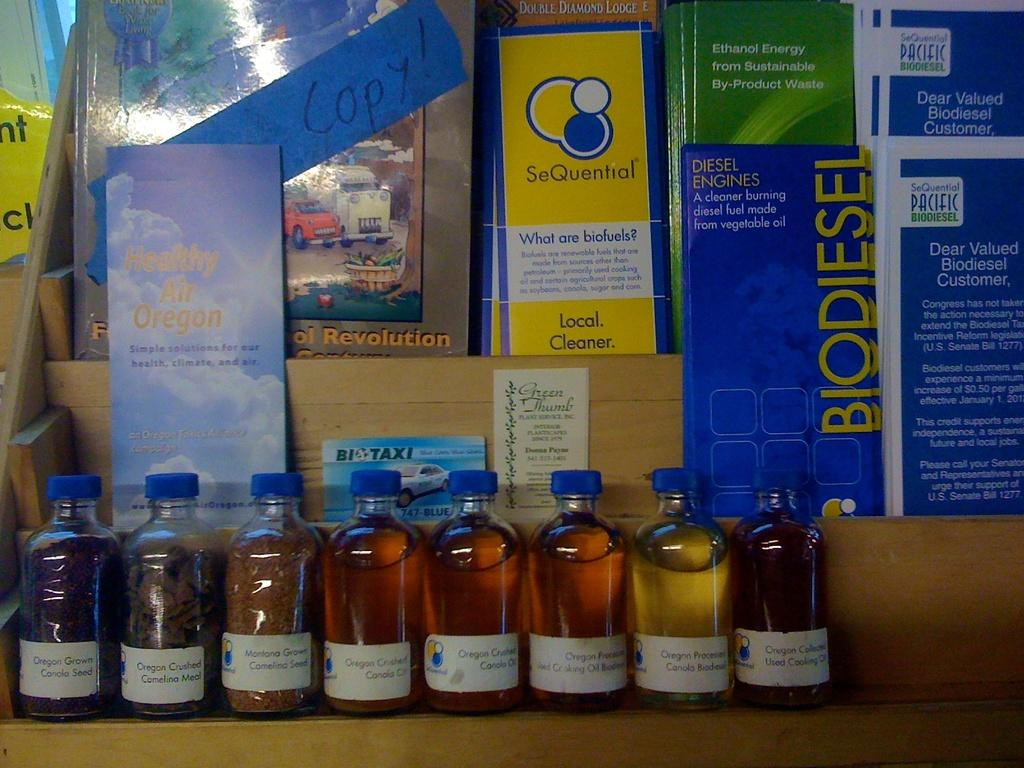What type of containers are present in the image? There are bottles with oil in the image. What is the material of the shelf in the image? There is a wooden shelf in the image. What items are placed on the wooden shelf? There are books on the wooden shelf. Can you describe the books on the shelf? There is text on the books. What is the name of the son who started the company in the image? There is no son or company mentioned in the image; it features bottles with oil, a wooden shelf, and books. 